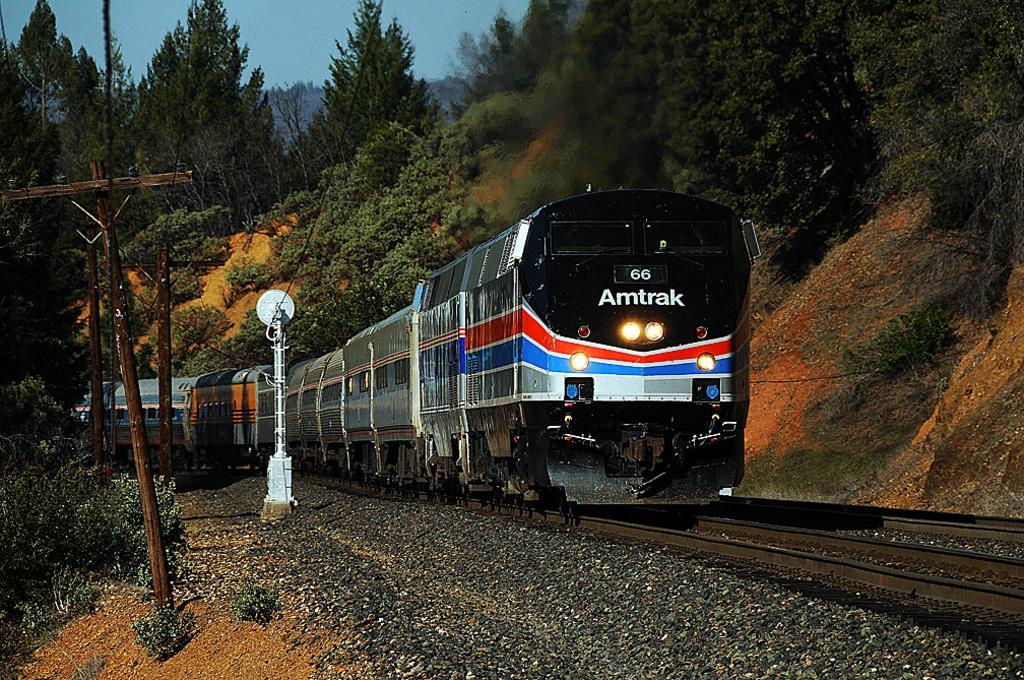What is the main subject of the image? The main subject of the image is a train. Where is the train located in the image? The train is on a train track. What can be seen in the background of the image? There are trees in the background of the image. What else is present in the image besides the train and trees? Current poles with cables are visible in the image. What type of meal is being served at the train station in the image? There is no train station or meal present in the image; it only features a train on a train track with trees and current poles with cables in the background. 